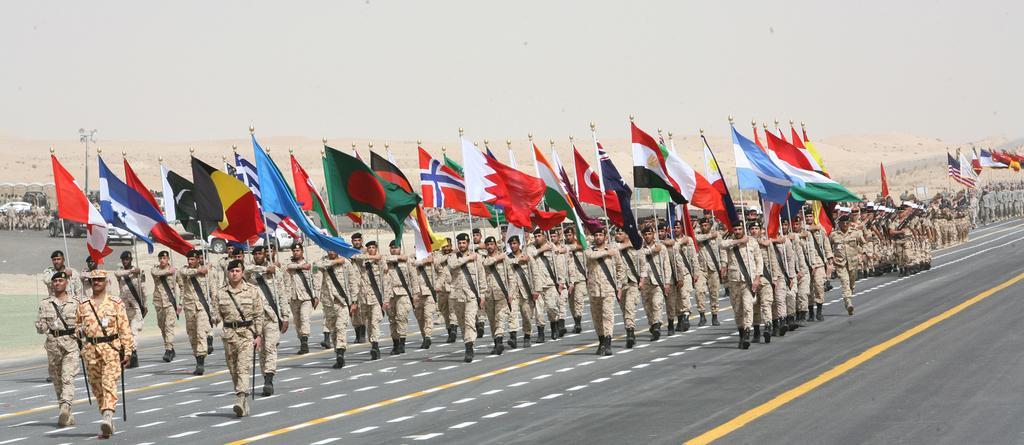How would you summarize this image in a sentence or two? In this image I can see group of people holding few flags and the flags are in multi color and the persons are wearing military dresses, background I can see few vehicles and the sky is in white color. 